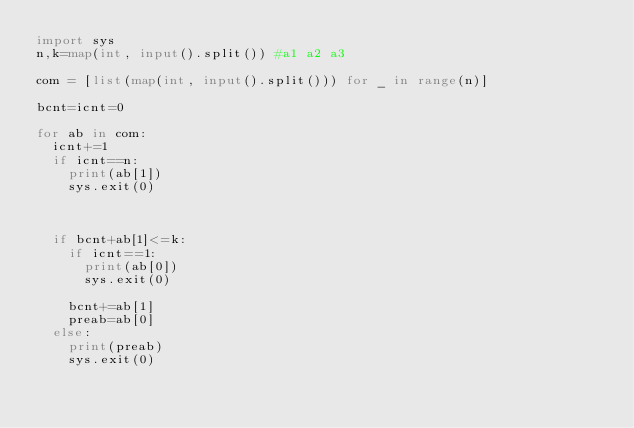<code> <loc_0><loc_0><loc_500><loc_500><_Python_>import sys
n,k=map(int, input().split()) #a1 a2 a3

com = [list(map(int, input().split())) for _ in range(n)]

bcnt=icnt=0

for ab in com:
  icnt+=1
  if icnt==n:
    print(ab[1])
    sys.exit(0)
  


  if bcnt+ab[1]<=k:
    if icnt==1:
      print(ab[0])
      sys.exit(0)

    bcnt+=ab[1]
    preab=ab[0]
  else:
    print(preab)
    sys.exit(0)</code> 